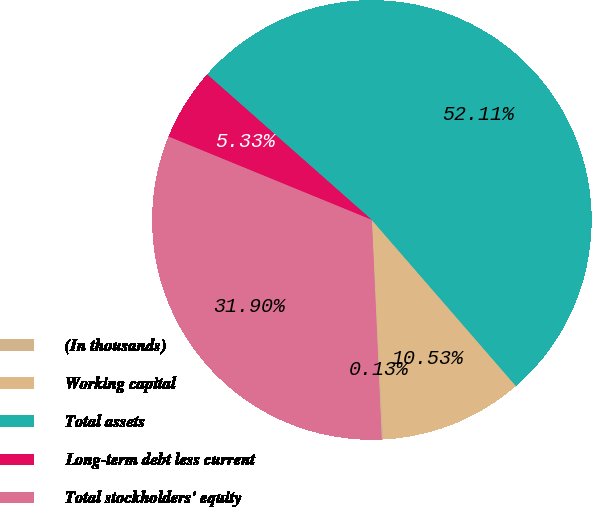<chart> <loc_0><loc_0><loc_500><loc_500><pie_chart><fcel>(In thousands)<fcel>Working capital<fcel>Total assets<fcel>Long-term debt less current<fcel>Total stockholders' equity<nl><fcel>0.13%<fcel>10.53%<fcel>52.1%<fcel>5.33%<fcel>31.9%<nl></chart> 